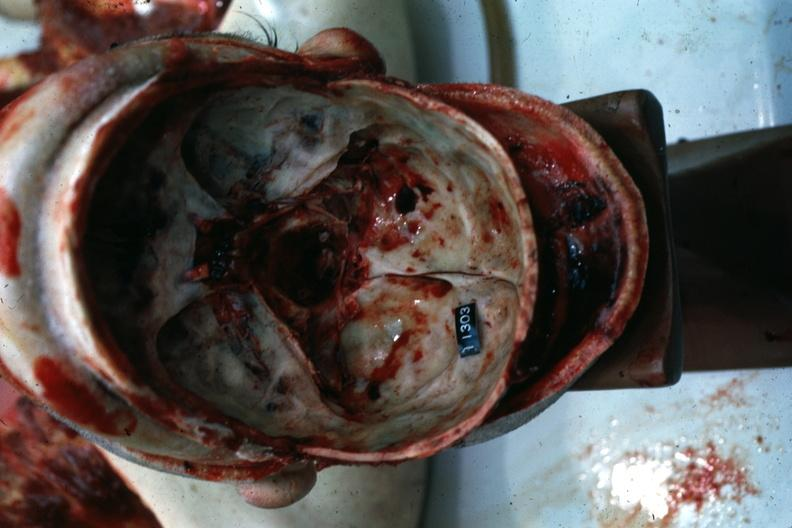what is present?
Answer the question using a single word or phrase. Basilar skull fracture 